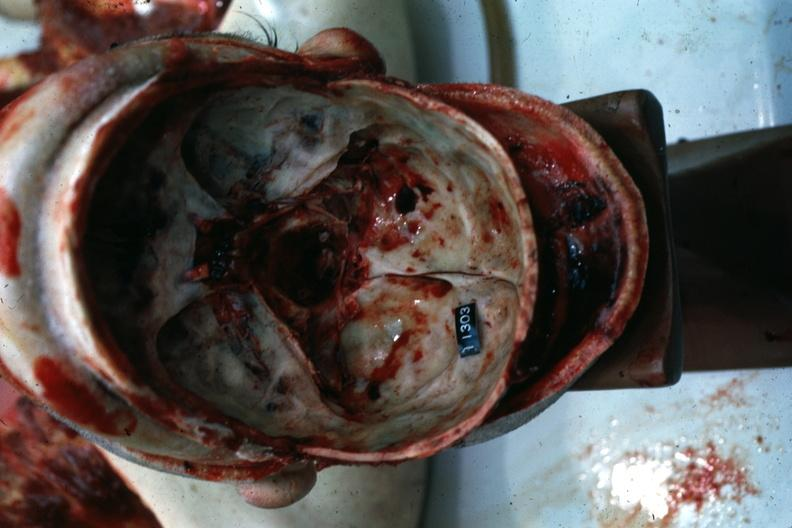what is present?
Answer the question using a single word or phrase. Basilar skull fracture 